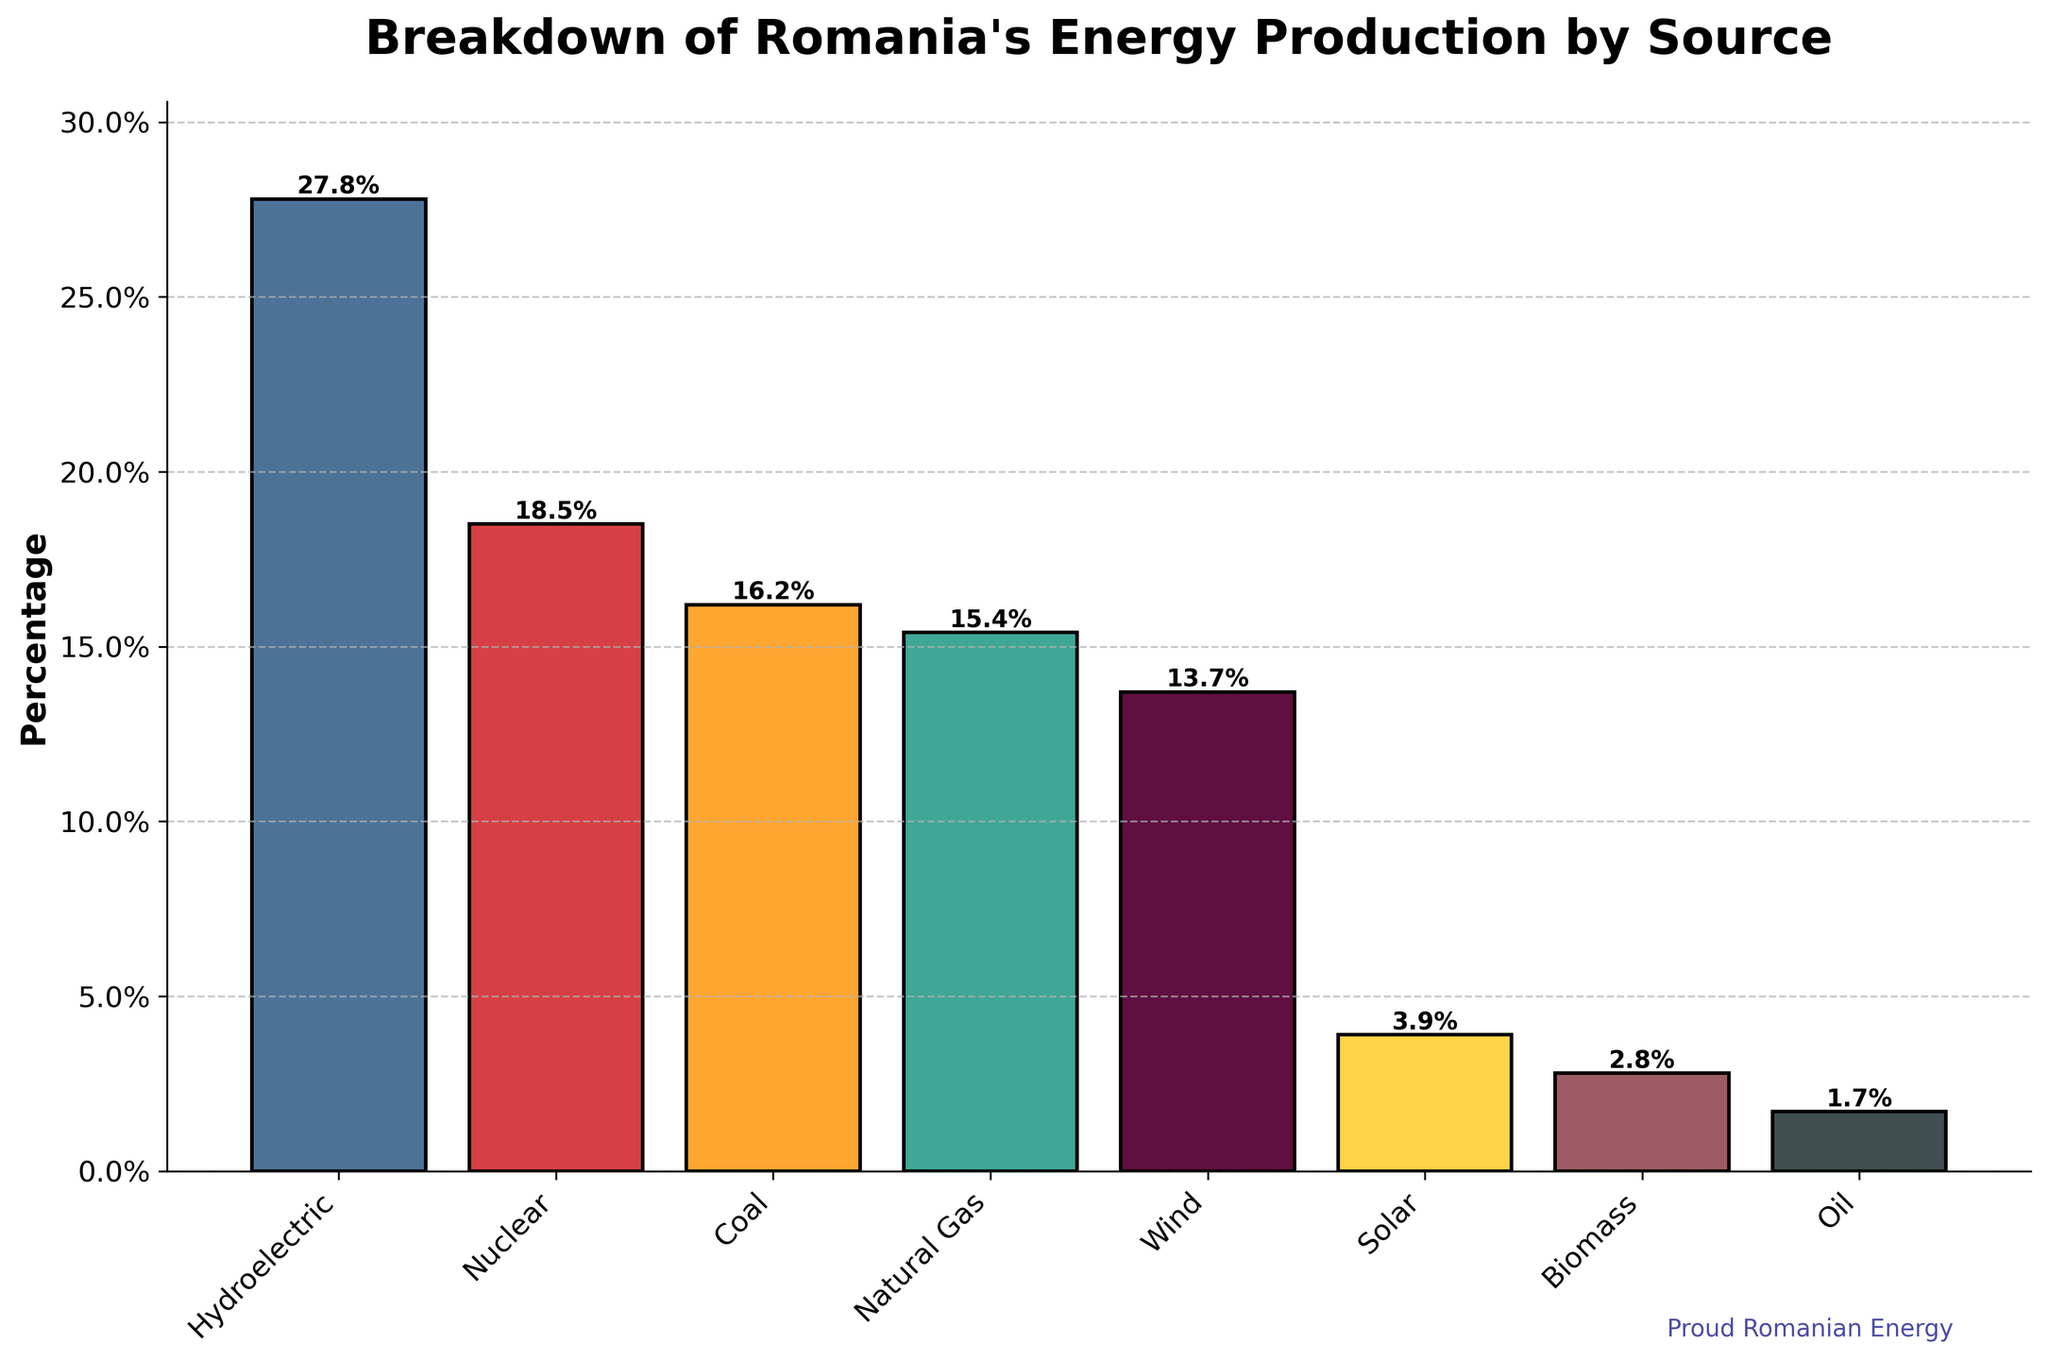What is the highest percentage of energy production by source in Romania? The highest percentage can be identified by looking for the tallest bar in the chart. The tallest bar indicates the energy source with 27.8%.
Answer: 27.8% Which energy source contributes the least to Romania's energy production? By identifying the shortest bar in the chart, which represents the smallest percentage, we see that oil contributes the least at 1.7%.
Answer: Oil What is the combined percentage of energy production from nuclear and coal sources? To find the combined percentage, sum the percentages for nuclear (18.5%) and coal (16.2%). The total is 18.5 + 16.2 = 34.7.
Answer: 34.7% How does the percentage of energy produced from natural gas compare to that from wind? Compare the heights of the bars for natural gas and wind. Natural gas has a percentage of 15.4%, and wind has 13.7%. Thus, natural gas contributes more.
Answer: Natural gas Which sources contribute more than 15% to Romania's energy production? Examine the bars and identify those with percentages above 15%. The sources are hydroelectric (27.8%), nuclear (18.5%), and coal (16.2%).
Answer: Hydroelectric, Nuclear, Coal What is the total percentage of renewable energy sources (hydroelectric, wind, solar, biomass) in Romania's energy production? Sum the percentages for hydroelectric (27.8%), wind (13.7%), solar (3.9%), and biomass (2.8%). The total is 27.8 + 13.7 + 3.9 + 2.8 = 48.2.
Answer: 48.2% Which has a higher percentage: solar or biomass? Compare the heights of the bars for solar and biomass. Solar has a percentage of 3.9%, while biomass is 2.8%. Thus, solar is higher.
Answer: Solar What is the difference in percentage between the top two energy sources? Identify the top two energy sources (hydroelectric and nuclear), then subtract the lower percentage (nuclear 18.5%) from the higher one (hydroelectric 27.8%). The difference is 27.8 - 18.5 = 9.3.
Answer: 9.3 How much more energy is produced from coal than oil? Subtract the percentage of oil (1.7%) from the percentage of coal (16.2%). The difference is 16.2 - 1.7 = 14.5.
Answer: 14.5 